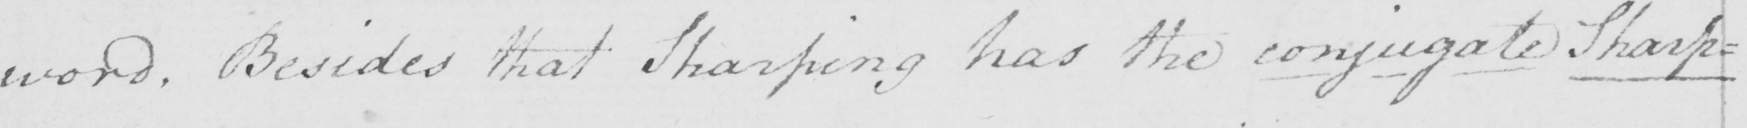Can you tell me what this handwritten text says? word . Besides that Sharping has the conjugate Sharp= 